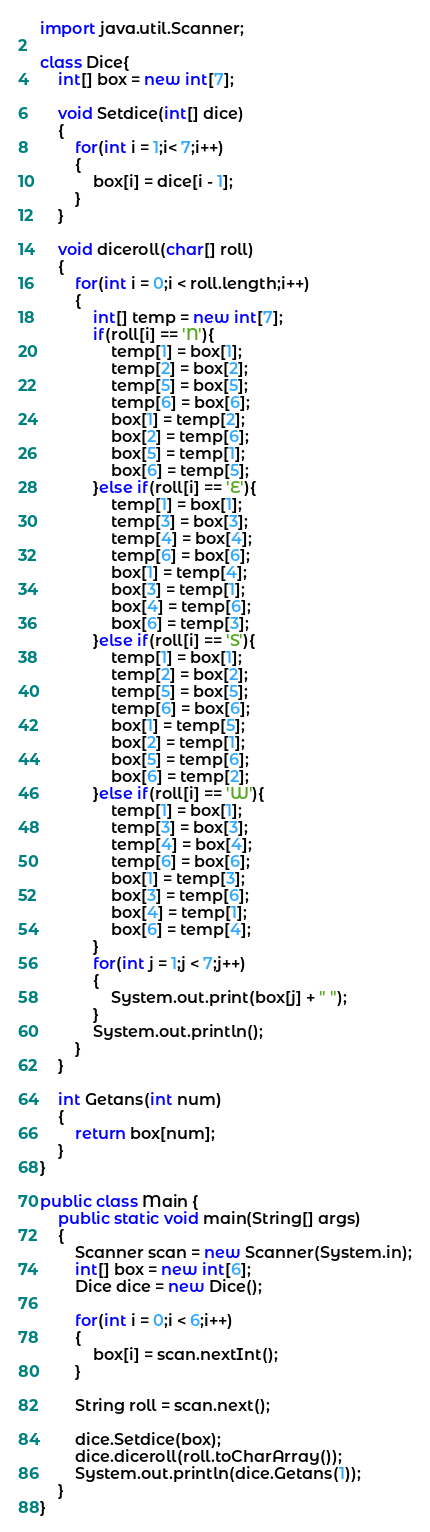<code> <loc_0><loc_0><loc_500><loc_500><_Java_>import java.util.Scanner;

class Dice{
	int[] box = new int[7];
	
	void Setdice(int[] dice)
	{
		for(int i = 1;i< 7;i++)
		{
			box[i] = dice[i - 1];
		}
	}
	
	void diceroll(char[] roll)
	{
		for(int i = 0;i < roll.length;i++)
		{
			int[] temp = new int[7];
			if(roll[i] == 'N'){
				temp[1] = box[1];
				temp[2] = box[2];
				temp[5] = box[5];
				temp[6] = box[6];
				box[1] = temp[2];
				box[2] = temp[6];
				box[5] = temp[1];
				box[6] = temp[5];
			}else if(roll[i] == 'E'){
				temp[1] = box[1];
				temp[3] = box[3];
				temp[4] = box[4];
				temp[6] = box[6];
				box[1] = temp[4];
				box[3] = temp[1];
				box[4] = temp[6];
				box[6] = temp[3];
			}else if(roll[i] == 'S'){
				temp[1] = box[1];
				temp[2] = box[2];
				temp[5] = box[5];
				temp[6] = box[6];
				box[1] = temp[5];
				box[2] = temp[1];
				box[5] = temp[6];
				box[6] = temp[2];
			}else if(roll[i] == 'W'){
				temp[1] = box[1];
				temp[3] = box[3];
				temp[4] = box[4];
				temp[6] = box[6];
				box[1] = temp[3];
				box[3] = temp[6];
				box[4] = temp[1];
				box[6] = temp[4];
			}
			for(int j = 1;j < 7;j++)
			{
				System.out.print(box[j] + " ");
			}
			System.out.println();
		}
	}
	
	int Getans(int num)
	{
		return box[num];
	}
}

public class Main {
	public static void main(String[] args)
	{
		Scanner scan = new Scanner(System.in);
		int[] box = new int[6];
		Dice dice = new Dice();
		
		for(int i = 0;i < 6;i++)
		{
			box[i] = scan.nextInt();
		}
		
		String roll = scan.next();
		
		dice.Setdice(box);
		dice.diceroll(roll.toCharArray());
		System.out.println(dice.Getans(1));
	}
}</code> 